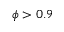Convert formula to latex. <formula><loc_0><loc_0><loc_500><loc_500>\phi > 0 . 9</formula> 